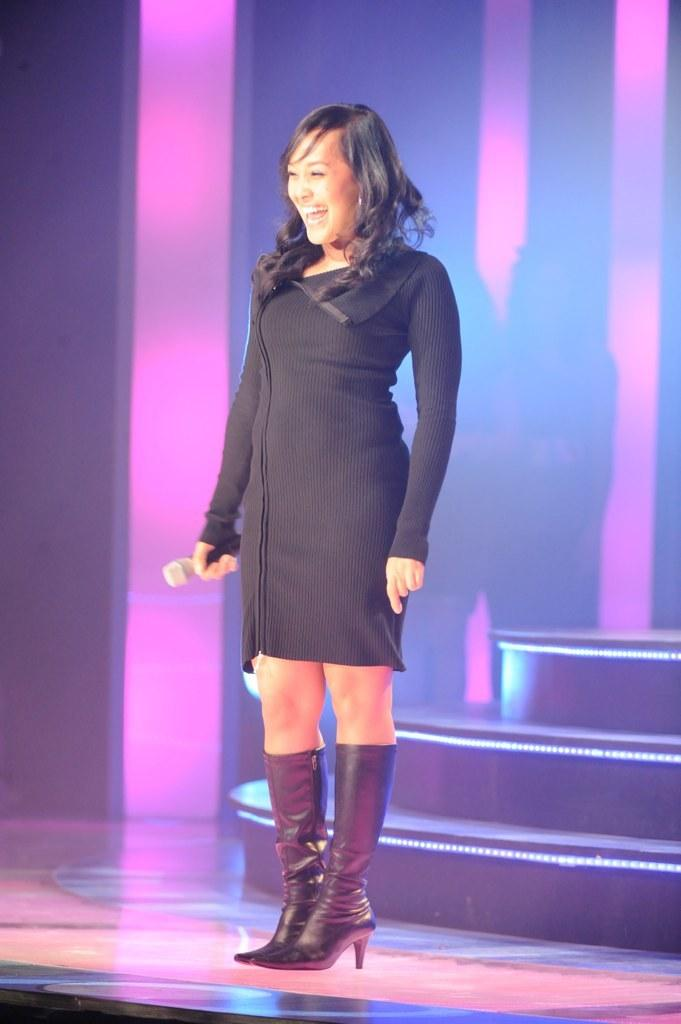Who is present in the image? There is a woman in the image. What is the woman doing in the image? The woman is standing on the floor. What is the woman holding in the image? The woman is holding an object. What can be seen in the background of the image? There are stairs and a wall visible in the background of the image. How many lizards are crawling on the woman's arm in the image? There are no lizards present in the image; the woman is holding an object, but no lizards are visible. 